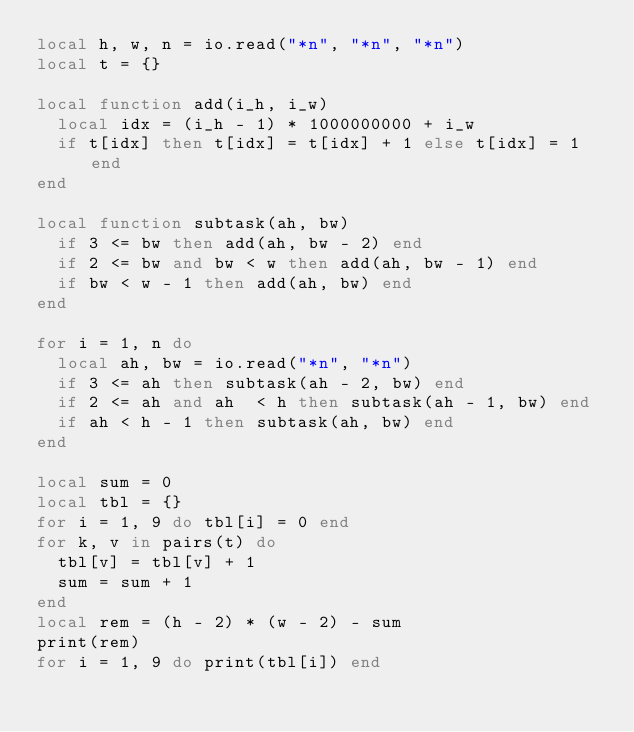<code> <loc_0><loc_0><loc_500><loc_500><_Lua_>local h, w, n = io.read("*n", "*n", "*n")
local t = {}

local function add(i_h, i_w)
  local idx = (i_h - 1) * 1000000000 + i_w
  if t[idx] then t[idx] = t[idx] + 1 else t[idx] = 1 end
end

local function subtask(ah, bw)
  if 3 <= bw then add(ah, bw - 2) end
  if 2 <= bw and bw < w then add(ah, bw - 1) end
  if bw < w - 1 then add(ah, bw) end
end

for i = 1, n do
  local ah, bw = io.read("*n", "*n")
  if 3 <= ah then subtask(ah - 2, bw) end
  if 2 <= ah and ah  < h then subtask(ah - 1, bw) end
  if ah < h - 1 then subtask(ah, bw) end
end

local sum = 0
local tbl = {}
for i = 1, 9 do tbl[i] = 0 end
for k, v in pairs(t) do
  tbl[v] = tbl[v] + 1
  sum = sum + 1
end
local rem = (h - 2) * (w - 2) - sum
print(rem)
for i = 1, 9 do print(tbl[i]) end
</code> 